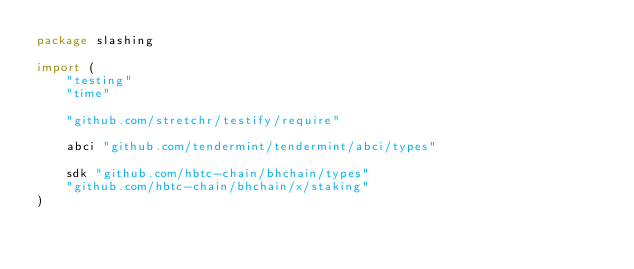<code> <loc_0><loc_0><loc_500><loc_500><_Go_>package slashing

import (
	"testing"
	"time"

	"github.com/stretchr/testify/require"

	abci "github.com/tendermint/tendermint/abci/types"

	sdk "github.com/hbtc-chain/bhchain/types"
	"github.com/hbtc-chain/bhchain/x/staking"
)
</code> 